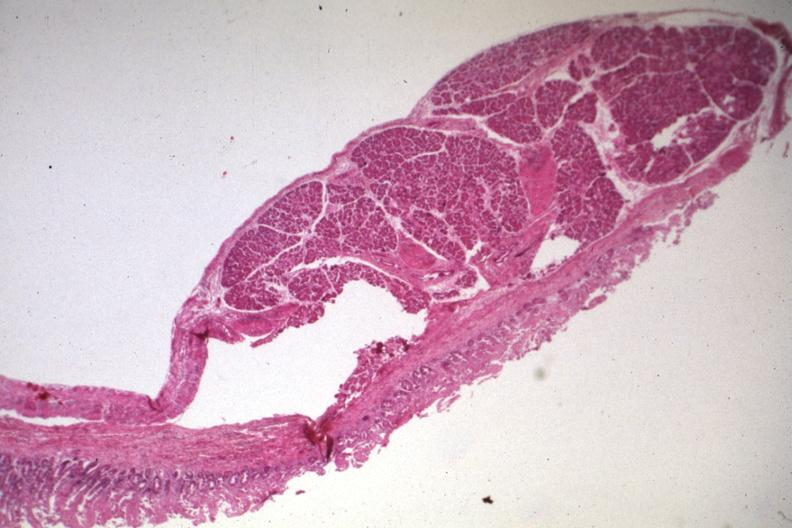s serous cystadenoma present?
Answer the question using a single word or phrase. No 